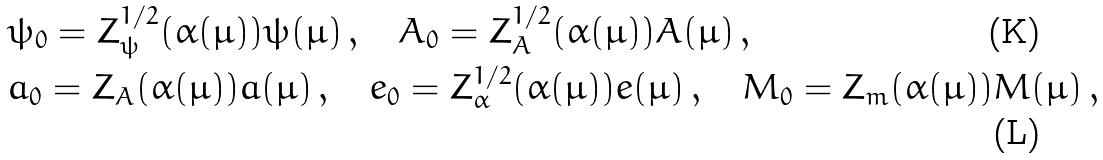<formula> <loc_0><loc_0><loc_500><loc_500>& \psi _ { 0 } = Z _ { \psi } ^ { 1 / 2 } ( \alpha ( \mu ) ) \psi ( \mu ) \, , \quad A _ { 0 } = Z _ { A } ^ { 1 / 2 } ( \alpha ( \mu ) ) A ( \mu ) \, , \\ & a _ { 0 } = Z _ { A } ( \alpha ( \mu ) ) a ( \mu ) \, , \quad e _ { 0 } = Z _ { \alpha } ^ { 1 / 2 } ( \alpha ( \mu ) ) e ( \mu ) \, , \quad M _ { 0 } = Z _ { m } ( \alpha ( \mu ) ) M ( \mu ) \, ,</formula> 